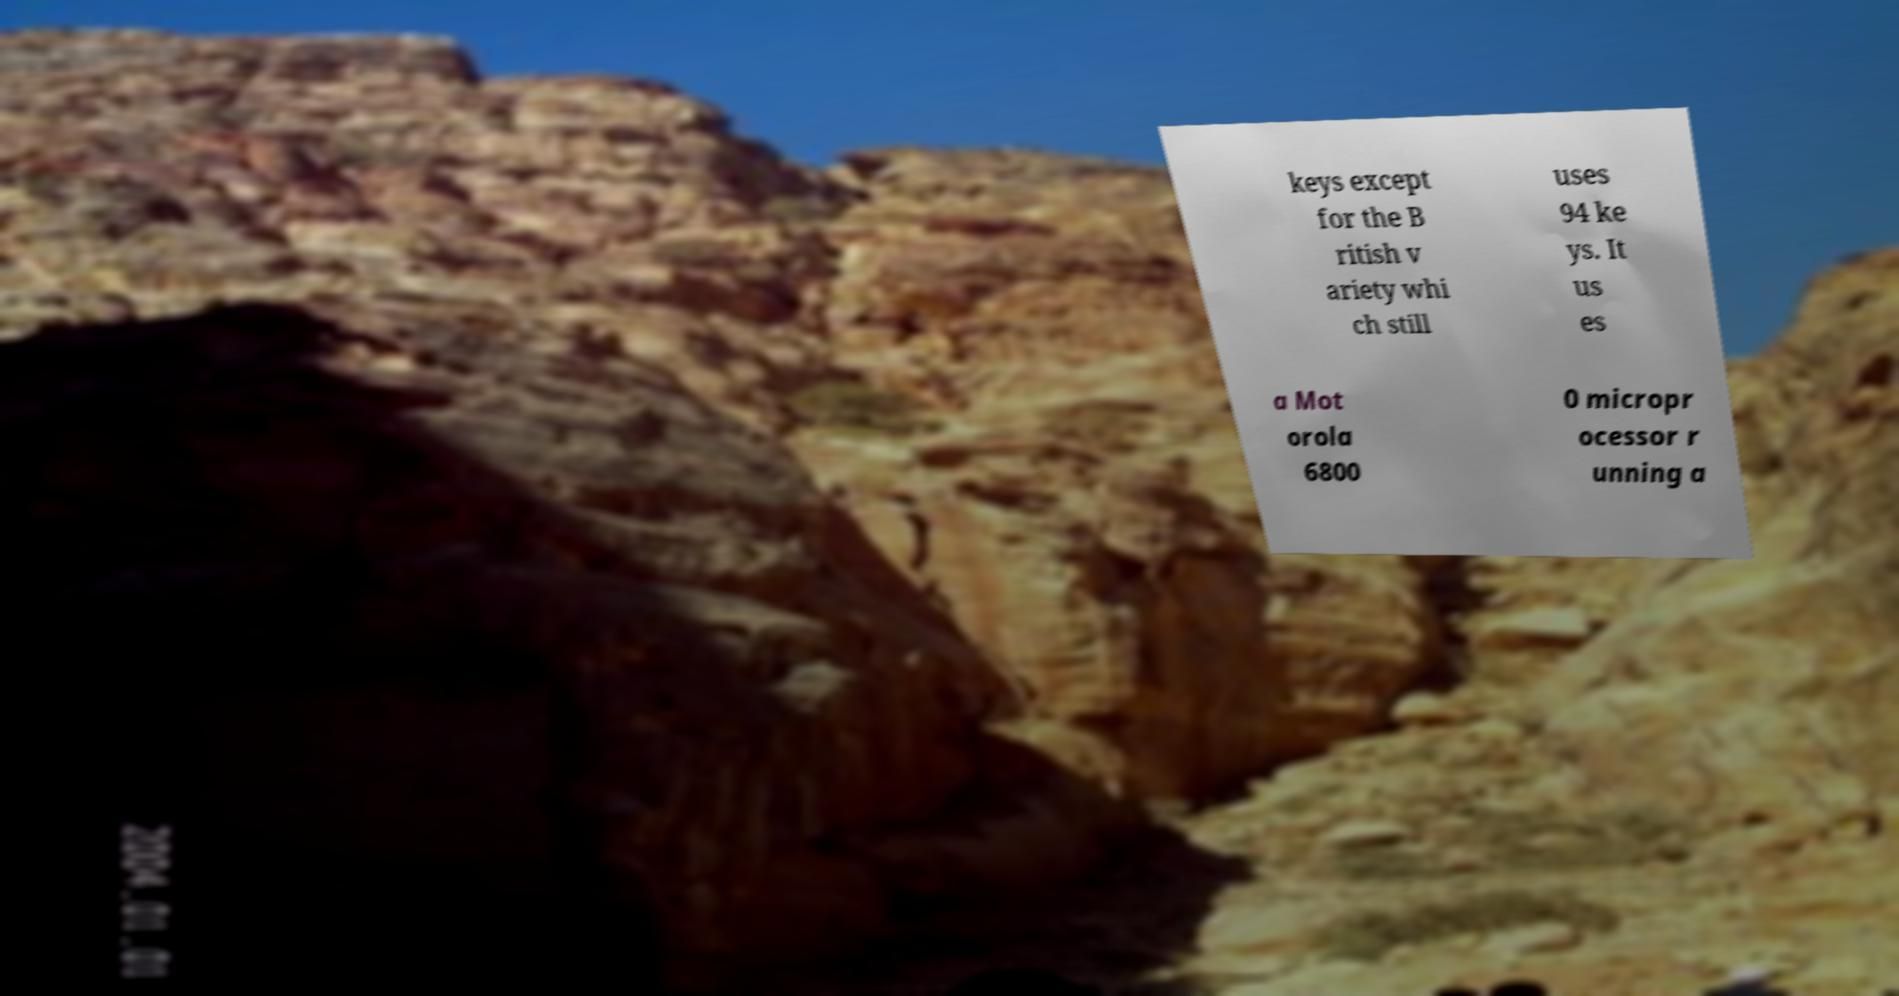There's text embedded in this image that I need extracted. Can you transcribe it verbatim? keys except for the B ritish v ariety whi ch still uses 94 ke ys. It us es a Mot orola 6800 0 micropr ocessor r unning a 